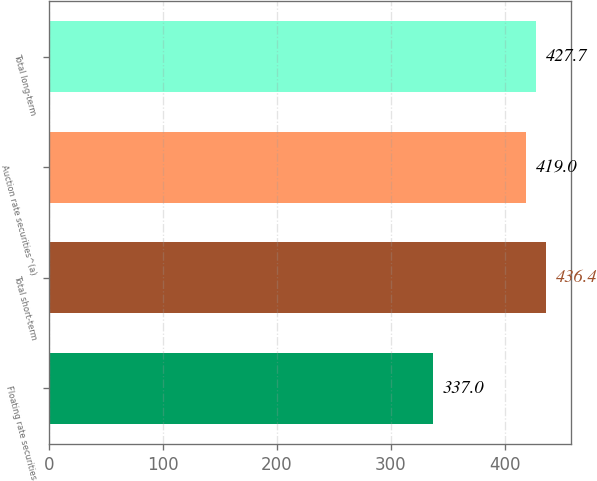<chart> <loc_0><loc_0><loc_500><loc_500><bar_chart><fcel>Floating rate securities<fcel>Total short-term<fcel>Auction rate securities^(a)<fcel>Total long-term<nl><fcel>337<fcel>436.4<fcel>419<fcel>427.7<nl></chart> 